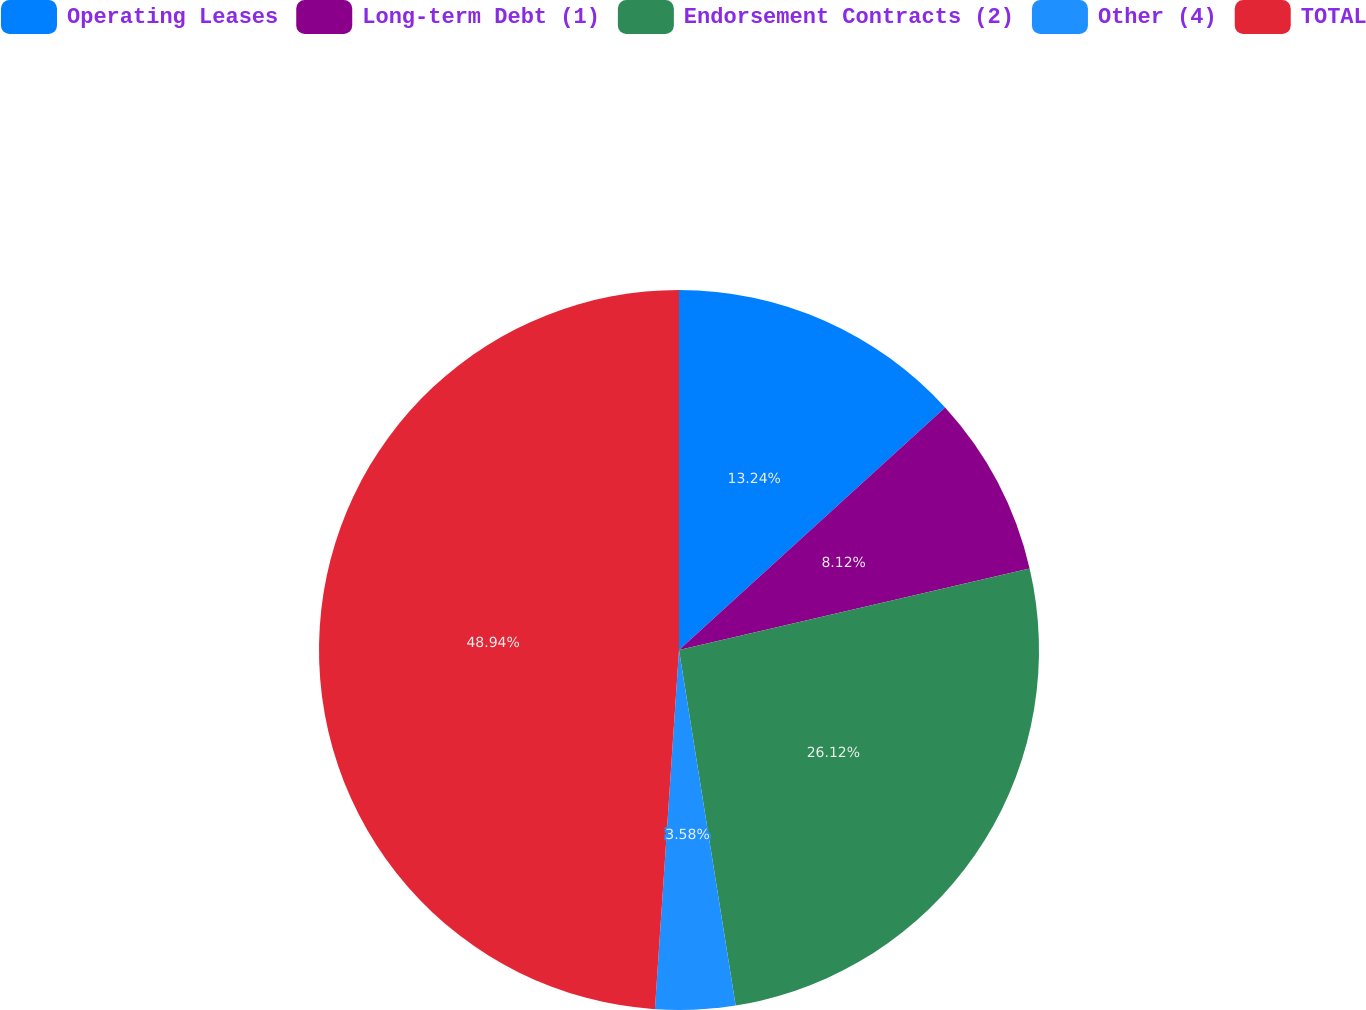Convert chart to OTSL. <chart><loc_0><loc_0><loc_500><loc_500><pie_chart><fcel>Operating Leases<fcel>Long-term Debt (1)<fcel>Endorsement Contracts (2)<fcel>Other (4)<fcel>TOTAL<nl><fcel>13.24%<fcel>8.12%<fcel>26.12%<fcel>3.58%<fcel>48.93%<nl></chart> 